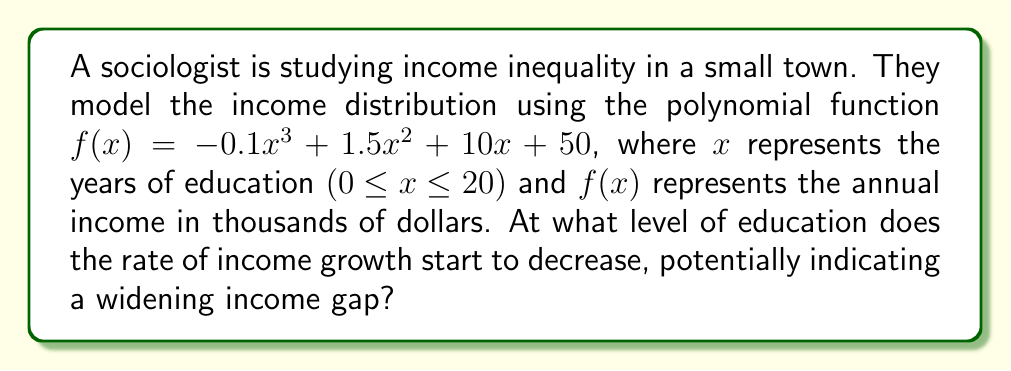Could you help me with this problem? To find the point where the rate of income growth starts to decrease, we need to analyze the function's rate of change. This is done by examining the derivative of the function.

1. First, let's find the derivative of $f(x)$:
   $f'(x) = -0.3x^2 + 3x + 10$

2. The rate of change starts to decrease at the maximum point of $f'(x)$. To find this, we need to find where the second derivative equals zero:
   $f''(x) = -0.6x + 3$

3. Set $f''(x) = 0$ and solve for $x$:
   $-0.6x + 3 = 0$
   $-0.6x = -3$
   $x = 5$

4. To confirm this is a maximum (not a minimum), we can check the sign of $f''(x)$ on either side of $x = 5$:
   For $x < 5$, $f''(x) > 0$
   For $x > 5$, $f''(x) < 0$
   This confirms $x = 5$ is indeed a maximum of $f'(x)$

5. Therefore, the rate of income growth starts to decrease after 5 years of education.

From a sociological perspective, this point represents where additional years of education begin to yield diminishing returns in terms of income growth. This could indicate a widening income gap between those with higher levels of education and those with lower levels, as the income growth rate slows down for those pursuing extended education.
Answer: The rate of income growth starts to decrease after 5 years of education. 